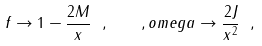<formula> <loc_0><loc_0><loc_500><loc_500>f \rightarrow 1 - \frac { 2 M } { x } \ , \quad , o m e g a \rightarrow \frac { 2 J } { x ^ { 2 } } \ ,</formula> 